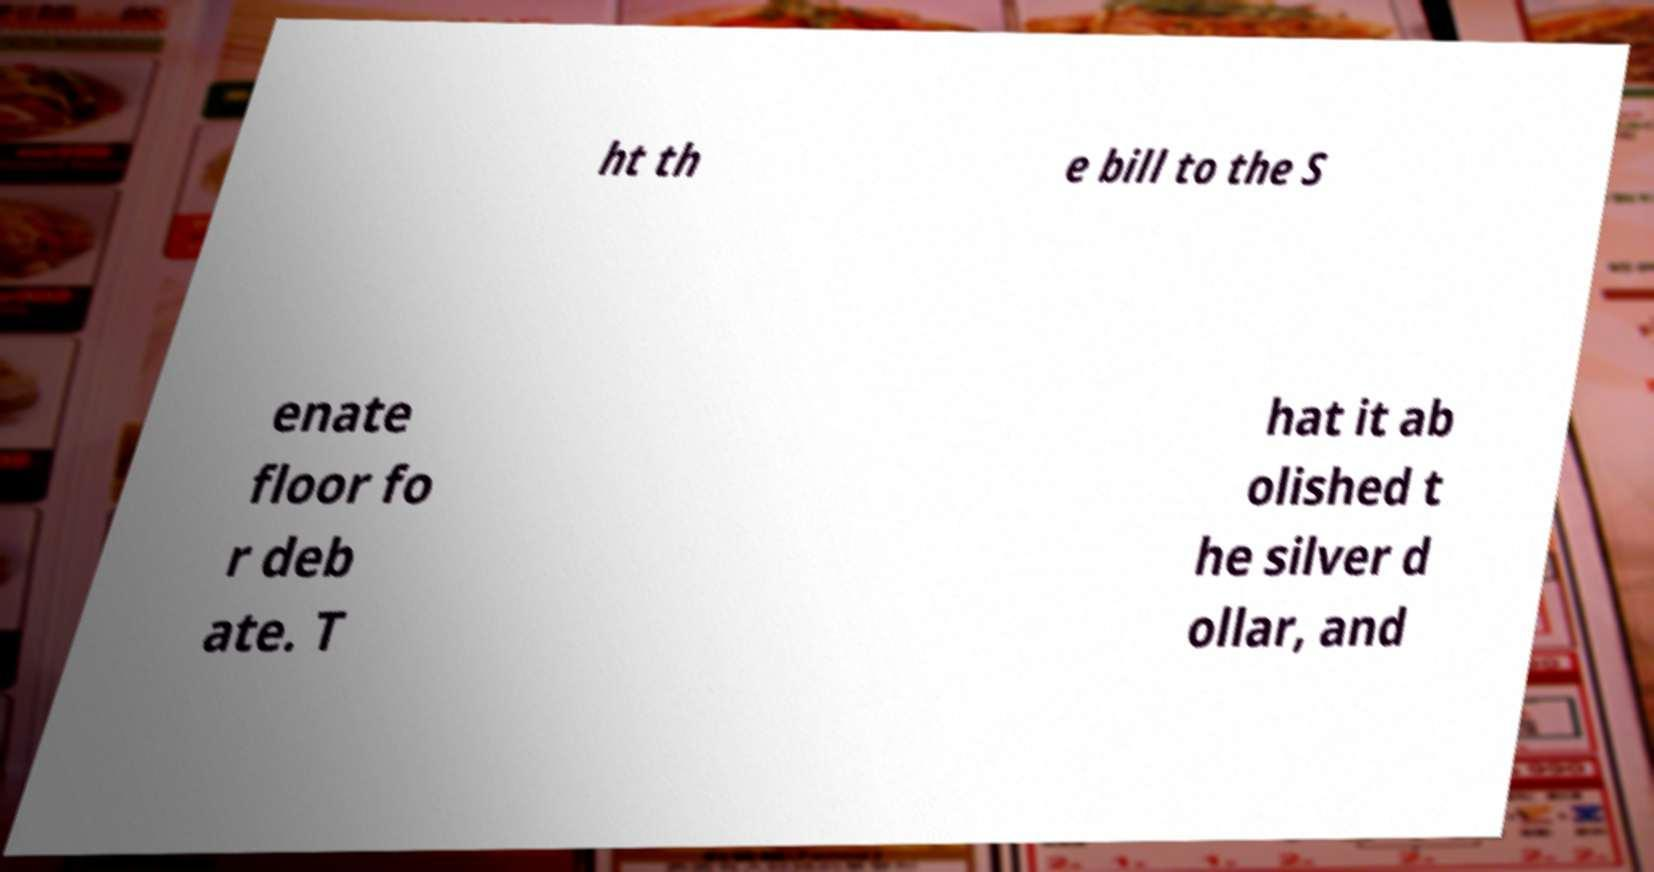I need the written content from this picture converted into text. Can you do that? ht th e bill to the S enate floor fo r deb ate. T hat it ab olished t he silver d ollar, and 